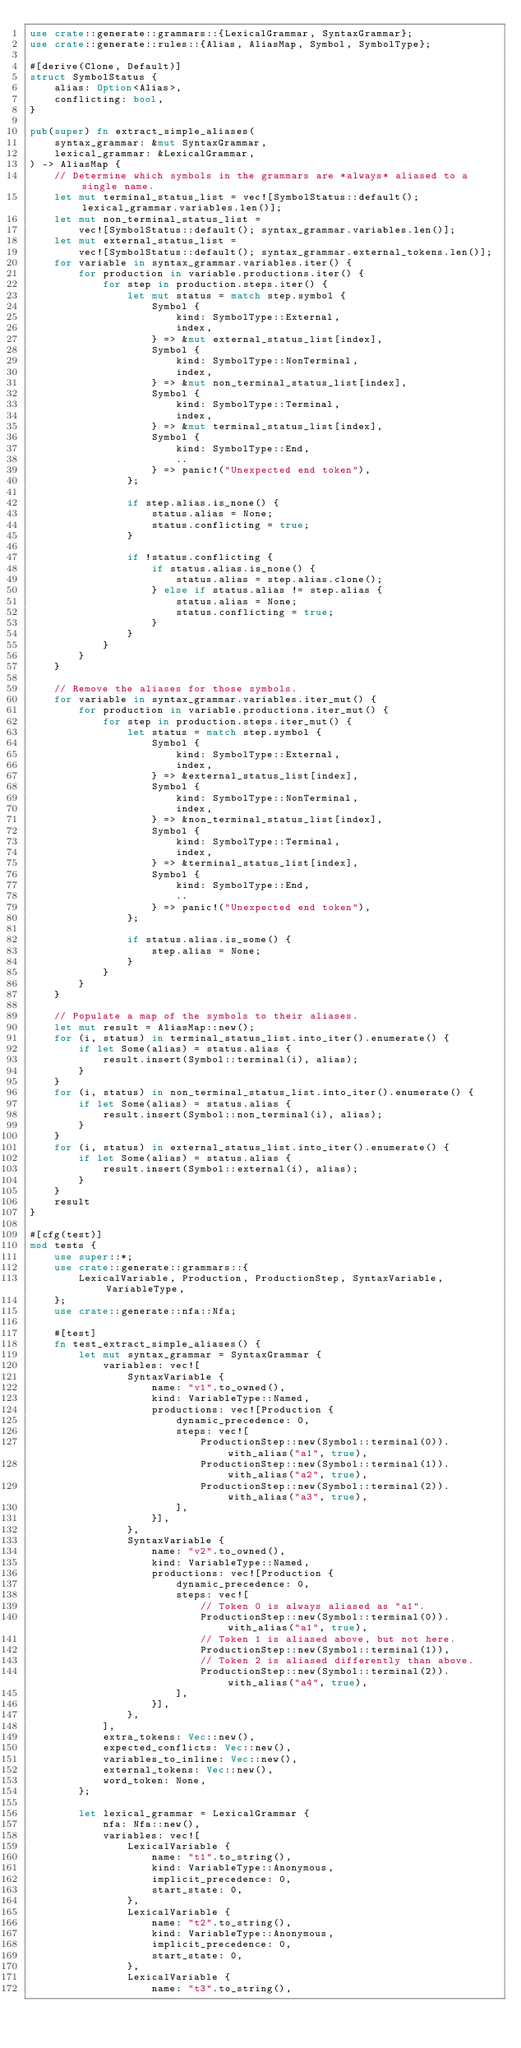Convert code to text. <code><loc_0><loc_0><loc_500><loc_500><_Rust_>use crate::generate::grammars::{LexicalGrammar, SyntaxGrammar};
use crate::generate::rules::{Alias, AliasMap, Symbol, SymbolType};

#[derive(Clone, Default)]
struct SymbolStatus {
    alias: Option<Alias>,
    conflicting: bool,
}

pub(super) fn extract_simple_aliases(
    syntax_grammar: &mut SyntaxGrammar,
    lexical_grammar: &LexicalGrammar,
) -> AliasMap {
    // Determine which symbols in the grammars are *always* aliased to a single name.
    let mut terminal_status_list = vec![SymbolStatus::default(); lexical_grammar.variables.len()];
    let mut non_terminal_status_list =
        vec![SymbolStatus::default(); syntax_grammar.variables.len()];
    let mut external_status_list =
        vec![SymbolStatus::default(); syntax_grammar.external_tokens.len()];
    for variable in syntax_grammar.variables.iter() {
        for production in variable.productions.iter() {
            for step in production.steps.iter() {
                let mut status = match step.symbol {
                    Symbol {
                        kind: SymbolType::External,
                        index,
                    } => &mut external_status_list[index],
                    Symbol {
                        kind: SymbolType::NonTerminal,
                        index,
                    } => &mut non_terminal_status_list[index],
                    Symbol {
                        kind: SymbolType::Terminal,
                        index,
                    } => &mut terminal_status_list[index],
                    Symbol {
                        kind: SymbolType::End,
                        ..
                    } => panic!("Unexpected end token"),
                };

                if step.alias.is_none() {
                    status.alias = None;
                    status.conflicting = true;
                }

                if !status.conflicting {
                    if status.alias.is_none() {
                        status.alias = step.alias.clone();
                    } else if status.alias != step.alias {
                        status.alias = None;
                        status.conflicting = true;
                    }
                }
            }
        }
    }

    // Remove the aliases for those symbols.
    for variable in syntax_grammar.variables.iter_mut() {
        for production in variable.productions.iter_mut() {
            for step in production.steps.iter_mut() {
                let status = match step.symbol {
                    Symbol {
                        kind: SymbolType::External,
                        index,
                    } => &external_status_list[index],
                    Symbol {
                        kind: SymbolType::NonTerminal,
                        index,
                    } => &non_terminal_status_list[index],
                    Symbol {
                        kind: SymbolType::Terminal,
                        index,
                    } => &terminal_status_list[index],
                    Symbol {
                        kind: SymbolType::End,
                        ..
                    } => panic!("Unexpected end token"),
                };

                if status.alias.is_some() {
                    step.alias = None;
                }
            }
        }
    }

    // Populate a map of the symbols to their aliases.
    let mut result = AliasMap::new();
    for (i, status) in terminal_status_list.into_iter().enumerate() {
        if let Some(alias) = status.alias {
            result.insert(Symbol::terminal(i), alias);
        }
    }
    for (i, status) in non_terminal_status_list.into_iter().enumerate() {
        if let Some(alias) = status.alias {
            result.insert(Symbol::non_terminal(i), alias);
        }
    }
    for (i, status) in external_status_list.into_iter().enumerate() {
        if let Some(alias) = status.alias {
            result.insert(Symbol::external(i), alias);
        }
    }
    result
}

#[cfg(test)]
mod tests {
    use super::*;
    use crate::generate::grammars::{
        LexicalVariable, Production, ProductionStep, SyntaxVariable, VariableType,
    };
    use crate::generate::nfa::Nfa;

    #[test]
    fn test_extract_simple_aliases() {
        let mut syntax_grammar = SyntaxGrammar {
            variables: vec![
                SyntaxVariable {
                    name: "v1".to_owned(),
                    kind: VariableType::Named,
                    productions: vec![Production {
                        dynamic_precedence: 0,
                        steps: vec![
                            ProductionStep::new(Symbol::terminal(0)).with_alias("a1", true),
                            ProductionStep::new(Symbol::terminal(1)).with_alias("a2", true),
                            ProductionStep::new(Symbol::terminal(2)).with_alias("a3", true),
                        ],
                    }],
                },
                SyntaxVariable {
                    name: "v2".to_owned(),
                    kind: VariableType::Named,
                    productions: vec![Production {
                        dynamic_precedence: 0,
                        steps: vec![
                            // Token 0 is always aliased as "a1".
                            ProductionStep::new(Symbol::terminal(0)).with_alias("a1", true),
                            // Token 1 is aliased above, but not here.
                            ProductionStep::new(Symbol::terminal(1)),
                            // Token 2 is aliased differently than above.
                            ProductionStep::new(Symbol::terminal(2)).with_alias("a4", true),
                        ],
                    }],
                },
            ],
            extra_tokens: Vec::new(),
            expected_conflicts: Vec::new(),
            variables_to_inline: Vec::new(),
            external_tokens: Vec::new(),
            word_token: None,
        };

        let lexical_grammar = LexicalGrammar {
            nfa: Nfa::new(),
            variables: vec![
                LexicalVariable {
                    name: "t1".to_string(),
                    kind: VariableType::Anonymous,
                    implicit_precedence: 0,
                    start_state: 0,
                },
                LexicalVariable {
                    name: "t2".to_string(),
                    kind: VariableType::Anonymous,
                    implicit_precedence: 0,
                    start_state: 0,
                },
                LexicalVariable {
                    name: "t3".to_string(),</code> 